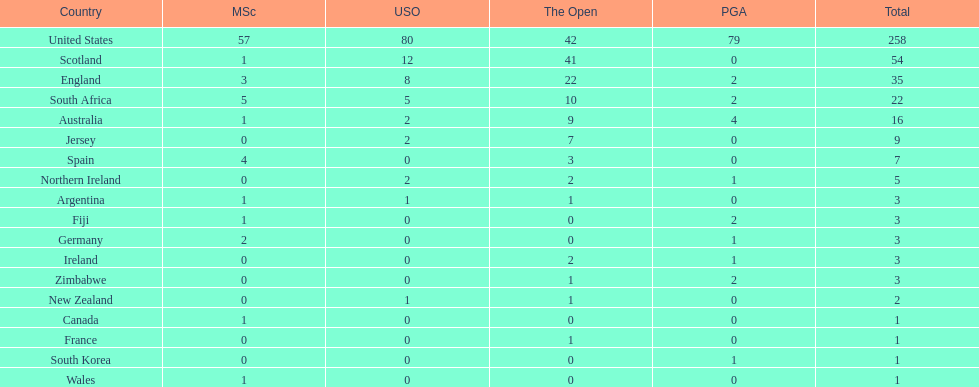How many total championships does spain have? 7. 